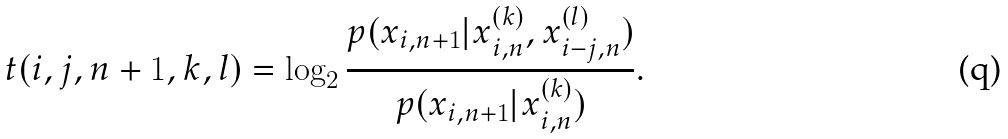<formula> <loc_0><loc_0><loc_500><loc_500>t ( i , j , n + 1 , k , l ) = \log _ { 2 } { \frac { p ( x _ { i , n + 1 } | x ^ { ( k ) } _ { i , n } , x ^ { ( l ) } _ { i - j , n } ) } { p ( x _ { i , n + 1 } | x ^ { ( k ) } _ { i , n } ) } } .</formula> 